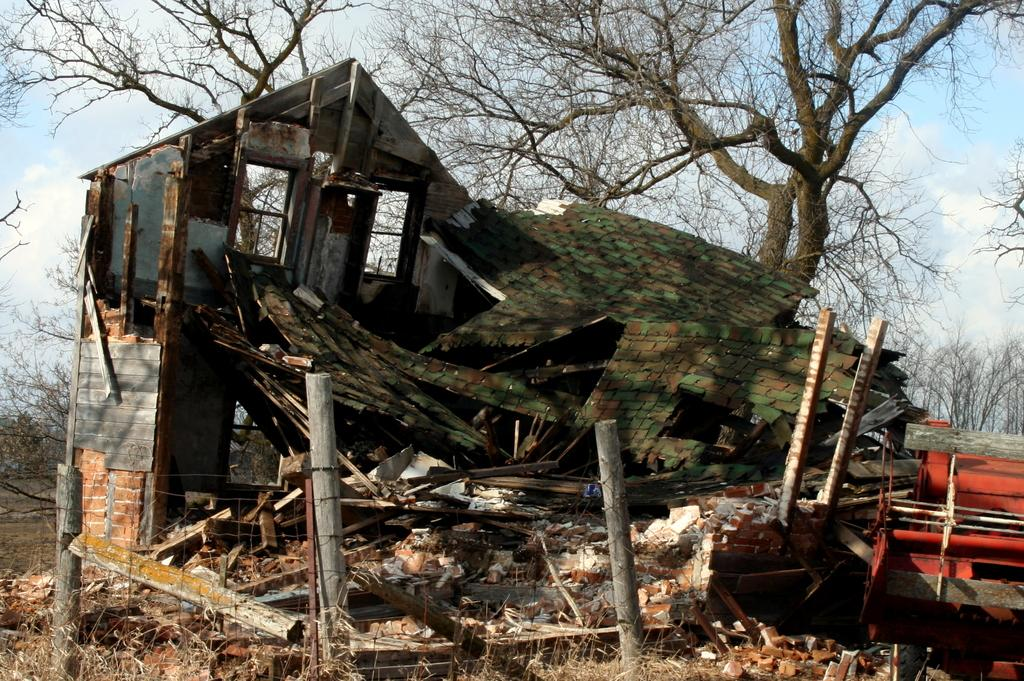What is the main subject of the image? There is a collapsed house in the image. What is located at the bottom of the image? There is fencing at the bottom of the image. What can be seen in the background of the image? There are many trees in the background of the image. What is visible on the right side of the image? The sky and clouds are visible on the right side of the image. What type of farm animals can be seen grazing in the image? There are no farm animals present in the image. What is the arm of the person doing in the image? There is no person or arm present in the image. 